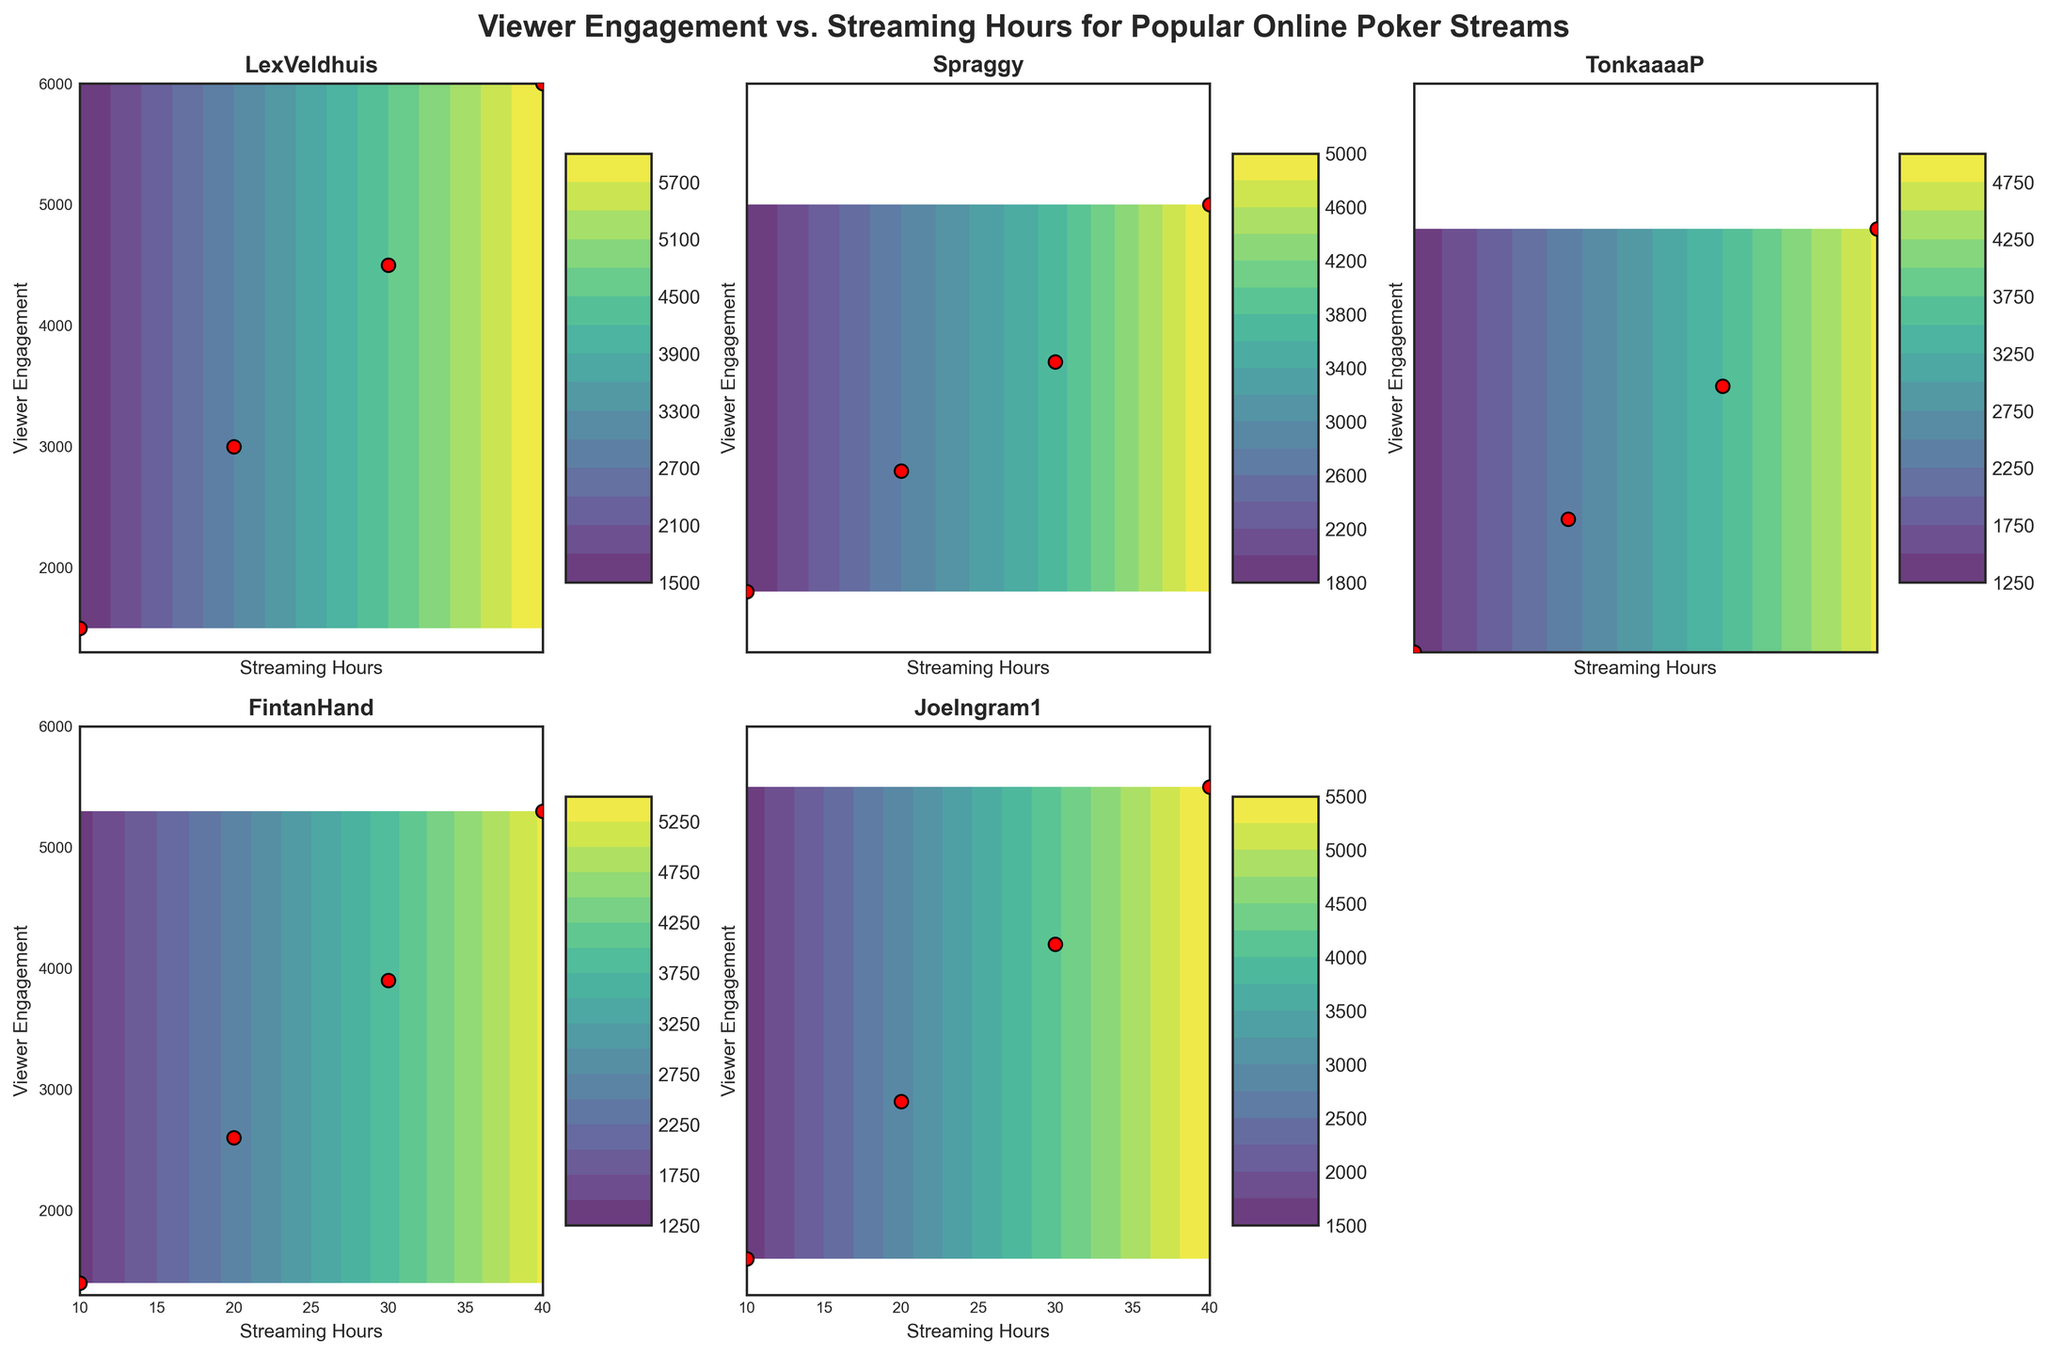What is the title of the figure? Look at the central header above all the subplots showing the main topic of the figure. The title is usually bold and larger than other text.
Answer: Viewer Engagement vs. Streaming Hours for Popular Online Poker Streams Which streamer has the highest Viewer Engagement at 40 streaming hours? Look at the Viewer Engagement axis for each subplot and identify which streamer has the greatest Viewer Engagement value at the 40 streaming hours mark.
Answer: LexVeldhuis Which streamer has the least Viewer Engagement at 10 streaming hours? Look at the Viewer Engagement axis for each subplot and compare the Viewer Engagement values at the 10 streaming hours mark across all streamers.
Answer: TonkaaaaP What color represents the highest viewer engagement values in the subplots? Focus on the color gradients in the contour maps. The highest values will be represented by the color at the extreme end of the gradient scale shown by the color bar.
Answer: Yellow How many subplots are displayed in the figure? Count the number of individual subplots arranged within the figure.
Answer: Five Between Spraggy and JoeIngram1, whose Viewer Engagement grows faster with increasing streaming hours? Compare the gradient and spacing of the contour lines and the slopes of the scatter points in the respective subplots of Spraggy and JoeIngram1.
Answer: JoeIngram1 For which streamer does Viewer Engagement have the most significant increase from 10 to 20 hours? Identify the change in Viewer Engagement between 10 and 20 hours for each streamer, then find the largest difference.
Answer: LexVeldhuis Looking at the subplot for FintanHand, what is the Viewer Engagement approximately when Streaming Hours are 25? Interpolate the value at 25 streaming hours by observing surrounding points and tiered contour lines to estimate the approximate Viewer Engagement.
Answer: Approximately 3250 Do any streamers have a Viewer Engagement value of around 5000 for less than 40 streaming hours? Check the subplot for each streamer to see if any reach a Viewer Engagement level of approximately 5000 before reaching 40 hours of streaming.
Answer: No 